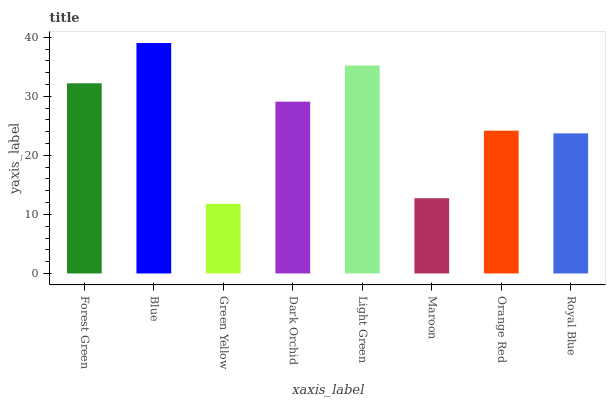Is Green Yellow the minimum?
Answer yes or no. Yes. Is Blue the maximum?
Answer yes or no. Yes. Is Blue the minimum?
Answer yes or no. No. Is Green Yellow the maximum?
Answer yes or no. No. Is Blue greater than Green Yellow?
Answer yes or no. Yes. Is Green Yellow less than Blue?
Answer yes or no. Yes. Is Green Yellow greater than Blue?
Answer yes or no. No. Is Blue less than Green Yellow?
Answer yes or no. No. Is Dark Orchid the high median?
Answer yes or no. Yes. Is Orange Red the low median?
Answer yes or no. Yes. Is Green Yellow the high median?
Answer yes or no. No. Is Forest Green the low median?
Answer yes or no. No. 